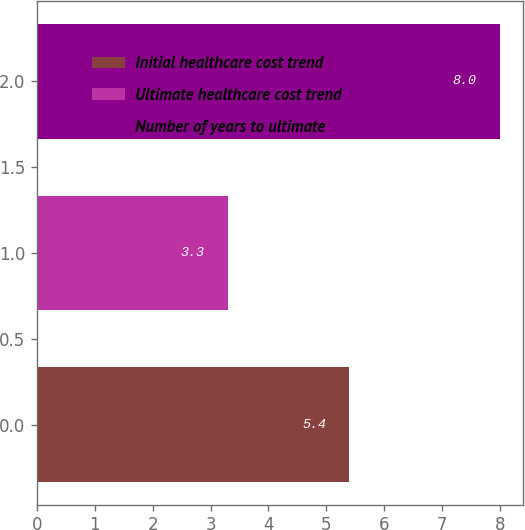Convert chart. <chart><loc_0><loc_0><loc_500><loc_500><bar_chart><fcel>Initial healthcare cost trend<fcel>Ultimate healthcare cost trend<fcel>Number of years to ultimate<nl><fcel>5.4<fcel>3.3<fcel>8<nl></chart> 